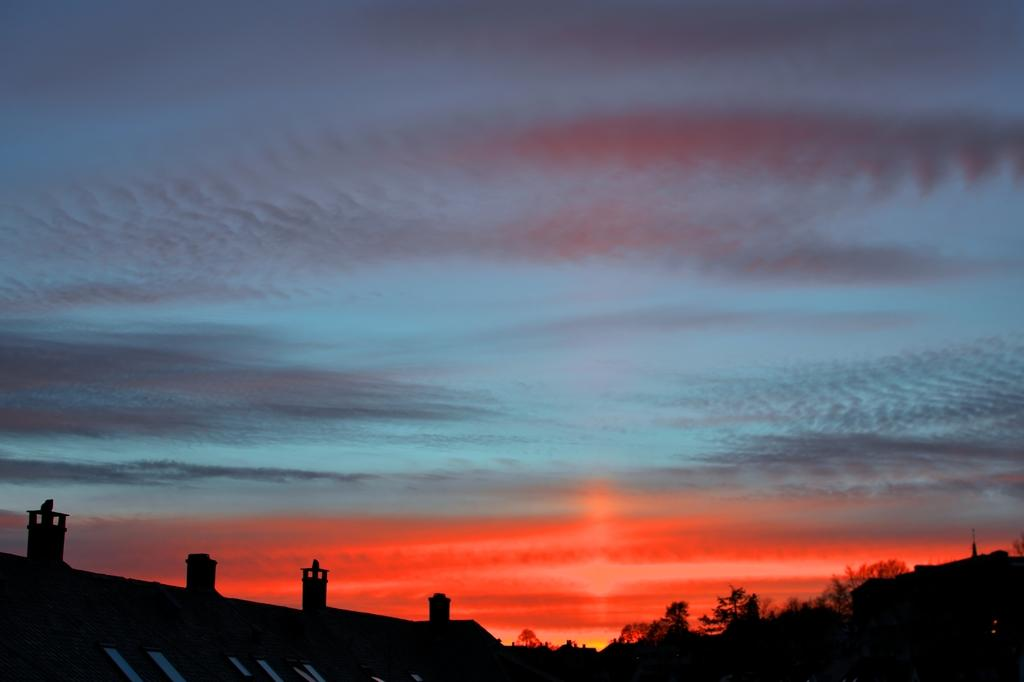What can be seen in the background of the image? There is a sky in the image. What is present in the sky? Clouds are visible in the image. What type of natural elements can be seen in the image? Trees are present in the image. What man-made objects are observable in the image? Poles are observable in the image. Can you see any jellyfish swimming in the sky in the image? There are no jellyfish present in the image; it features a sky with clouds. What letter is written on the trees in the image? There are no letters written on the trees in the image; they are natural elements. 